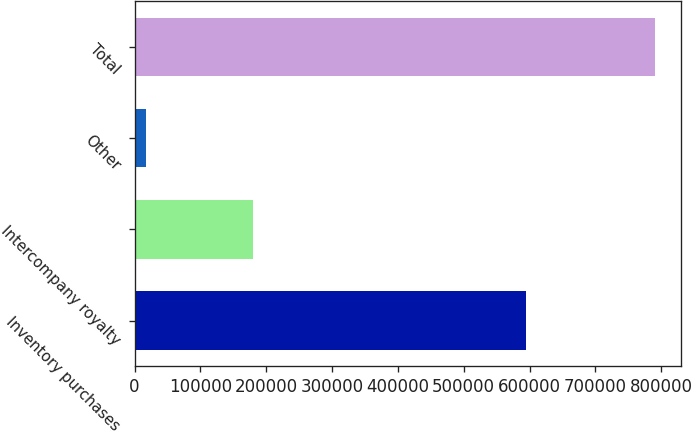Convert chart. <chart><loc_0><loc_0><loc_500><loc_500><bar_chart><fcel>Inventory purchases<fcel>Intercompany royalty<fcel>Other<fcel>Total<nl><fcel>593953<fcel>179308<fcel>17047<fcel>790308<nl></chart> 